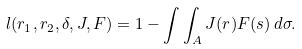<formula> <loc_0><loc_0><loc_500><loc_500>l ( r _ { 1 } , r _ { 2 } , \delta , J , F ) = 1 - \int \int _ { A } J ( r ) F ( s ) \, d \sigma .</formula> 